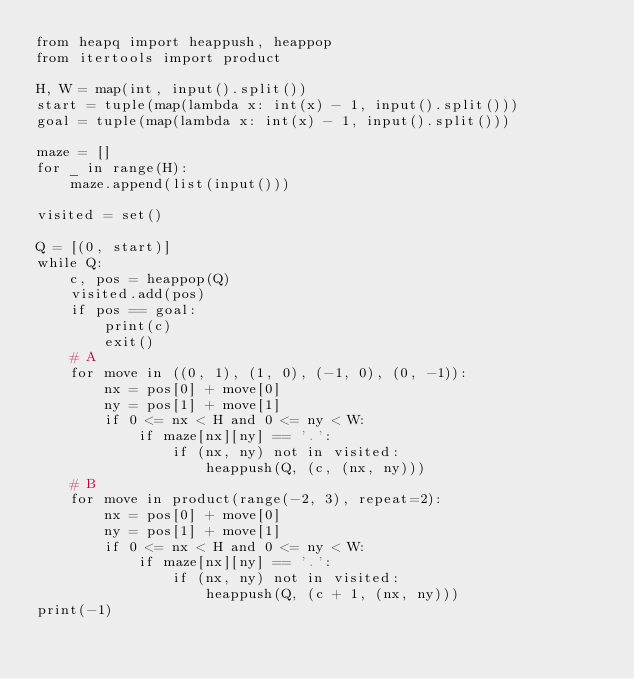Convert code to text. <code><loc_0><loc_0><loc_500><loc_500><_Python_>from heapq import heappush, heappop
from itertools import product

H, W = map(int, input().split())
start = tuple(map(lambda x: int(x) - 1, input().split()))
goal = tuple(map(lambda x: int(x) - 1, input().split()))

maze = []
for _ in range(H):
    maze.append(list(input()))

visited = set()

Q = [(0, start)]
while Q:
    c, pos = heappop(Q)
    visited.add(pos)
    if pos == goal:
        print(c)
        exit()
    # A
    for move in ((0, 1), (1, 0), (-1, 0), (0, -1)):
        nx = pos[0] + move[0]
        ny = pos[1] + move[1]
        if 0 <= nx < H and 0 <= ny < W:
            if maze[nx][ny] == '.':
                if (nx, ny) not in visited:
                    heappush(Q, (c, (nx, ny)))
    # B
    for move in product(range(-2, 3), repeat=2):
        nx = pos[0] + move[0]
        ny = pos[1] + move[1]
        if 0 <= nx < H and 0 <= ny < W:
            if maze[nx][ny] == '.':
                if (nx, ny) not in visited:
                    heappush(Q, (c + 1, (nx, ny)))
print(-1)

</code> 